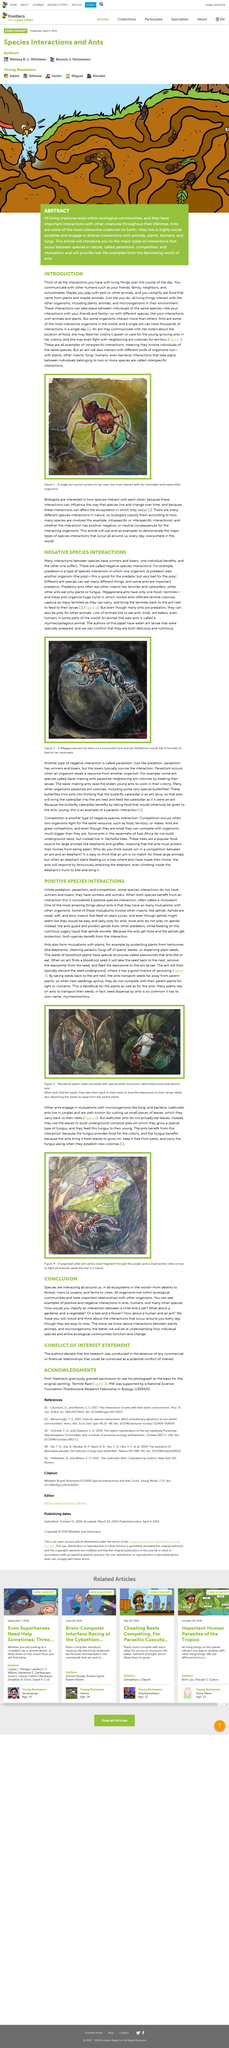Specify some key components in this picture. A myrmecophagous animal is an animal that eats ants. An ant can have thousands of interactions in just one day. Leafcutter ants are depicted in Figure 4. Megaponera ants are known to feed exclusively on termites, making them highly specialized predators in their ecosystem. Intraspecific interactions refer to interactions between individuals of the same species. 